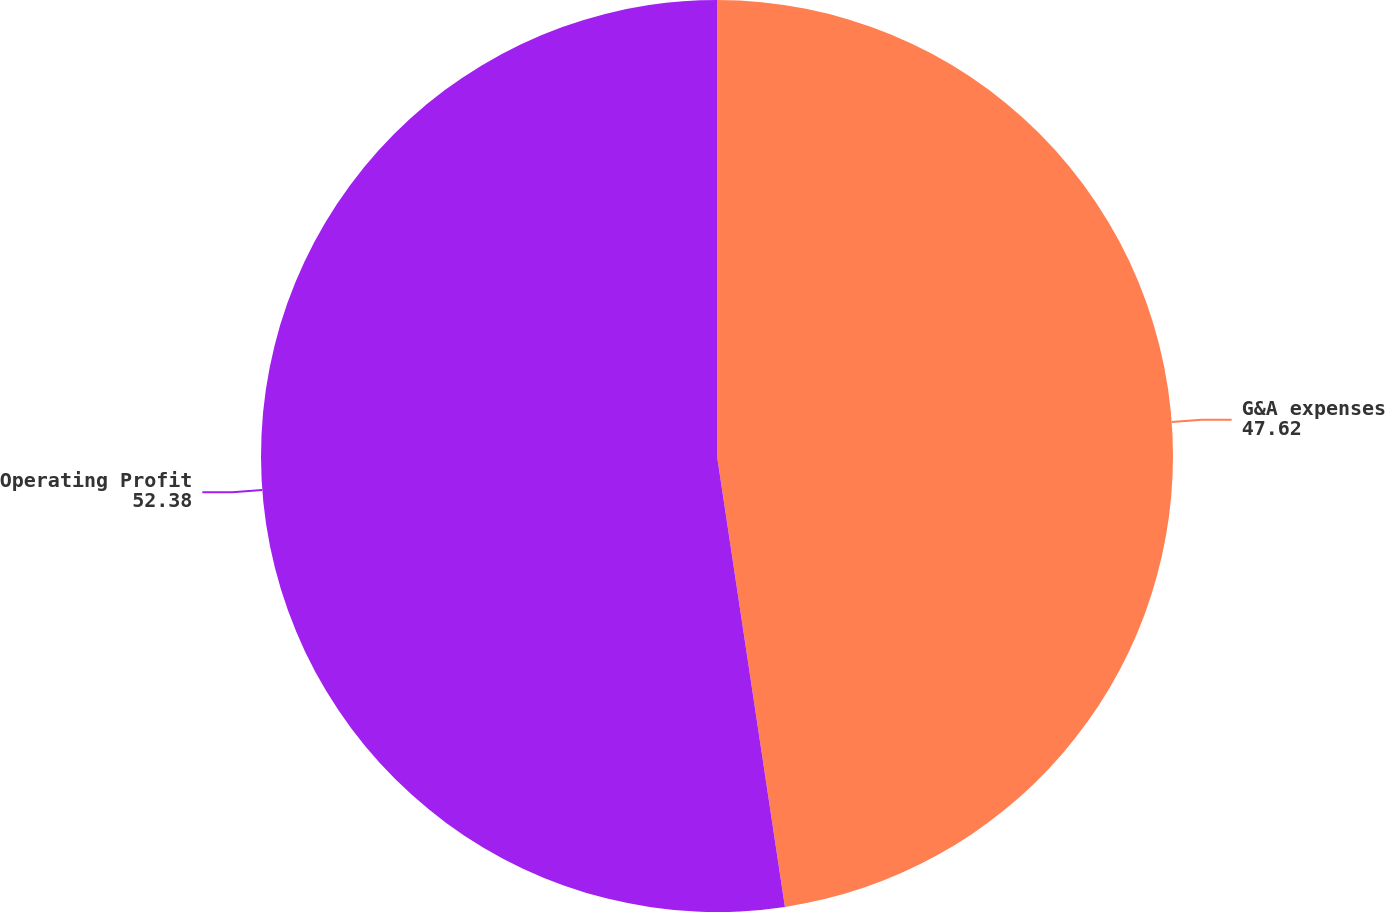Convert chart. <chart><loc_0><loc_0><loc_500><loc_500><pie_chart><fcel>G&A expenses<fcel>Operating Profit<nl><fcel>47.62%<fcel>52.38%<nl></chart> 